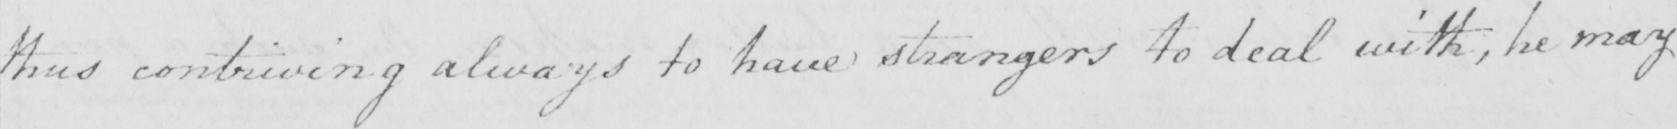Please provide the text content of this handwritten line. thus contriving always to have strangers to deal with , he may 